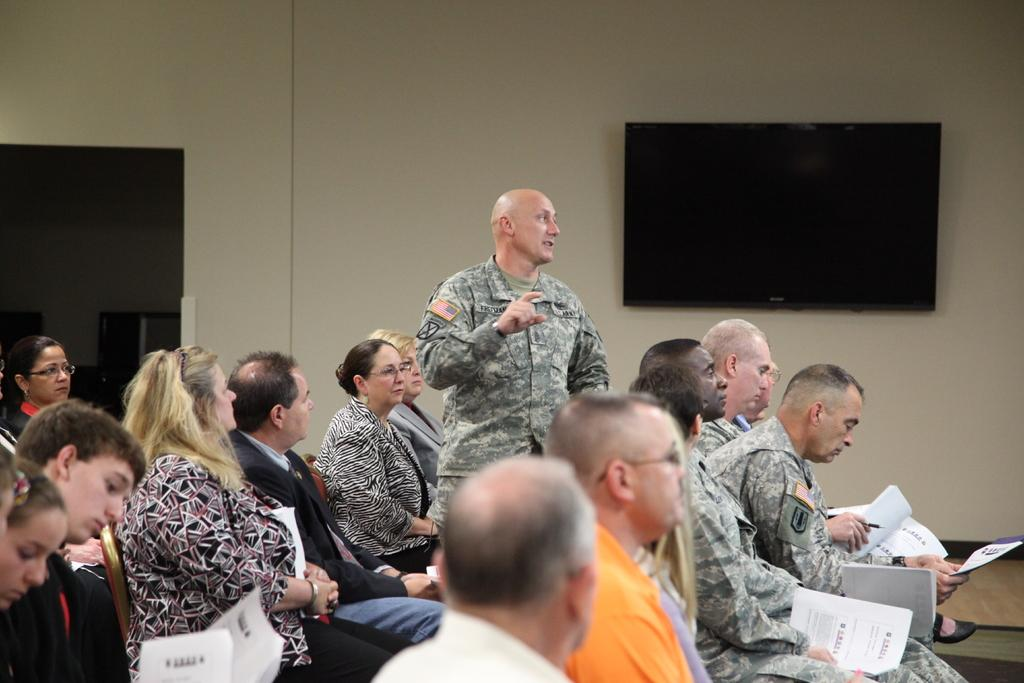How many people are visible in the image? There are many people sitting in the image. What are some people doing with the papers they are holding? Some people are holding papers, which suggests they might be reading or discussing them. What is the position of the person who is not sitting in the image? One person is standing. What can be seen on the wall in the background of the image? There is a TV on the wall. How many grapes are on the table in the image? There is no mention of grapes or a table in the image; it primarily features people sitting and holding papers. 